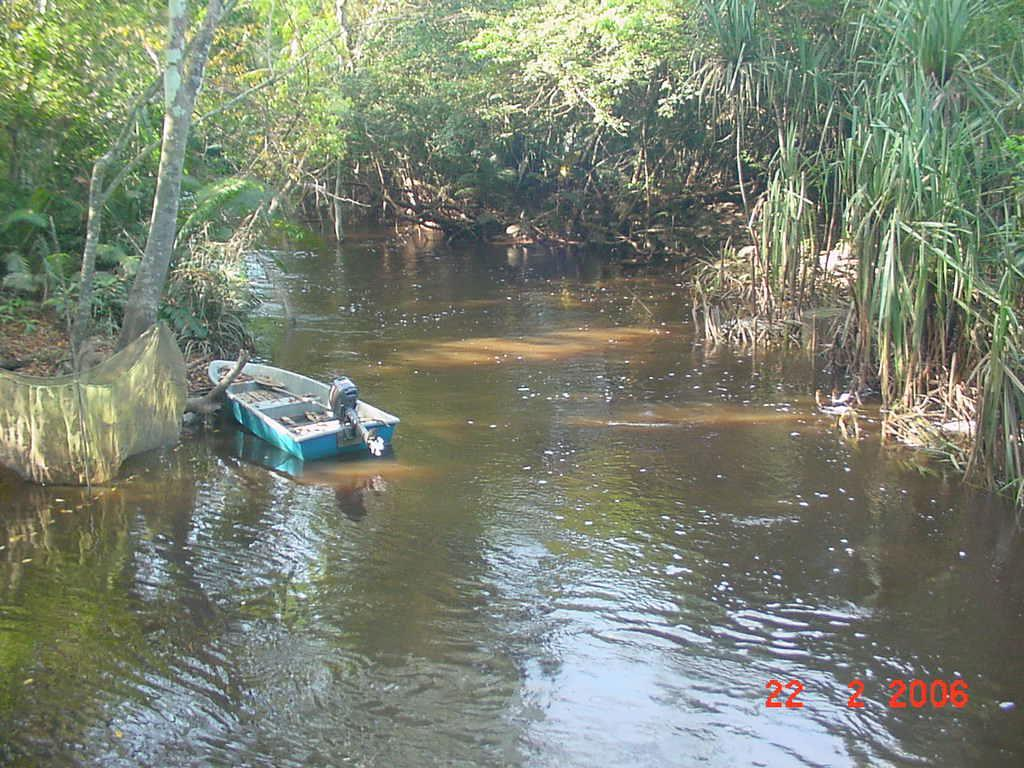What body of water is present in the image? There is a river in the image. What is on the river in the image? There is a boat on the river. What type of vegetation is present near the river? There are trees on the sides of the river. What can be seen in the right corner of the image? There is a watermark in the right corner of the image. What type of rake is being used by the son in the image? There is no son or rake present in the image. What book is the person reading in the image? There is no person reading a book in the image. 